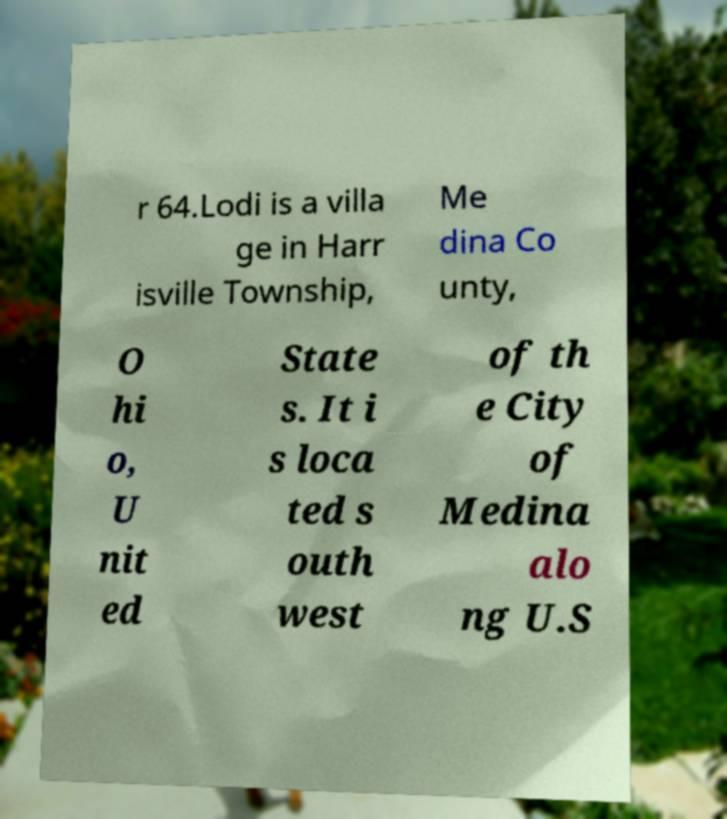What messages or text are displayed in this image? I need them in a readable, typed format. r 64.Lodi is a villa ge in Harr isville Township, Me dina Co unty, O hi o, U nit ed State s. It i s loca ted s outh west of th e City of Medina alo ng U.S 